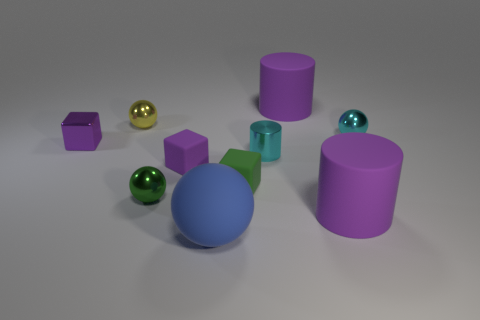Subtract all rubber cubes. How many cubes are left? 1 Subtract all green spheres. How many purple cylinders are left? 2 Subtract all purple cylinders. How many cylinders are left? 1 Subtract all cylinders. How many objects are left? 7 Subtract all blue cubes. Subtract all cyan balls. How many cubes are left? 3 Subtract all large purple rubber objects. Subtract all balls. How many objects are left? 4 Add 4 green shiny things. How many green shiny things are left? 5 Add 5 large blue balls. How many large blue balls exist? 6 Subtract 2 purple cylinders. How many objects are left? 8 